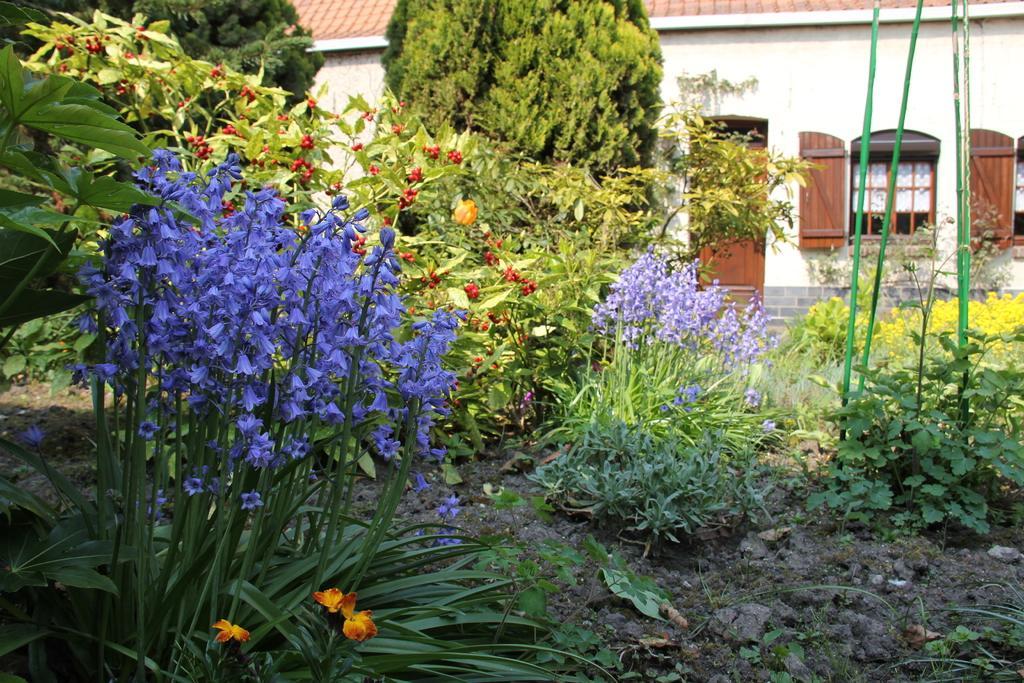How would you summarize this image in a sentence or two? In this image we can see flowers, plants, trees, windows, doors and house. 